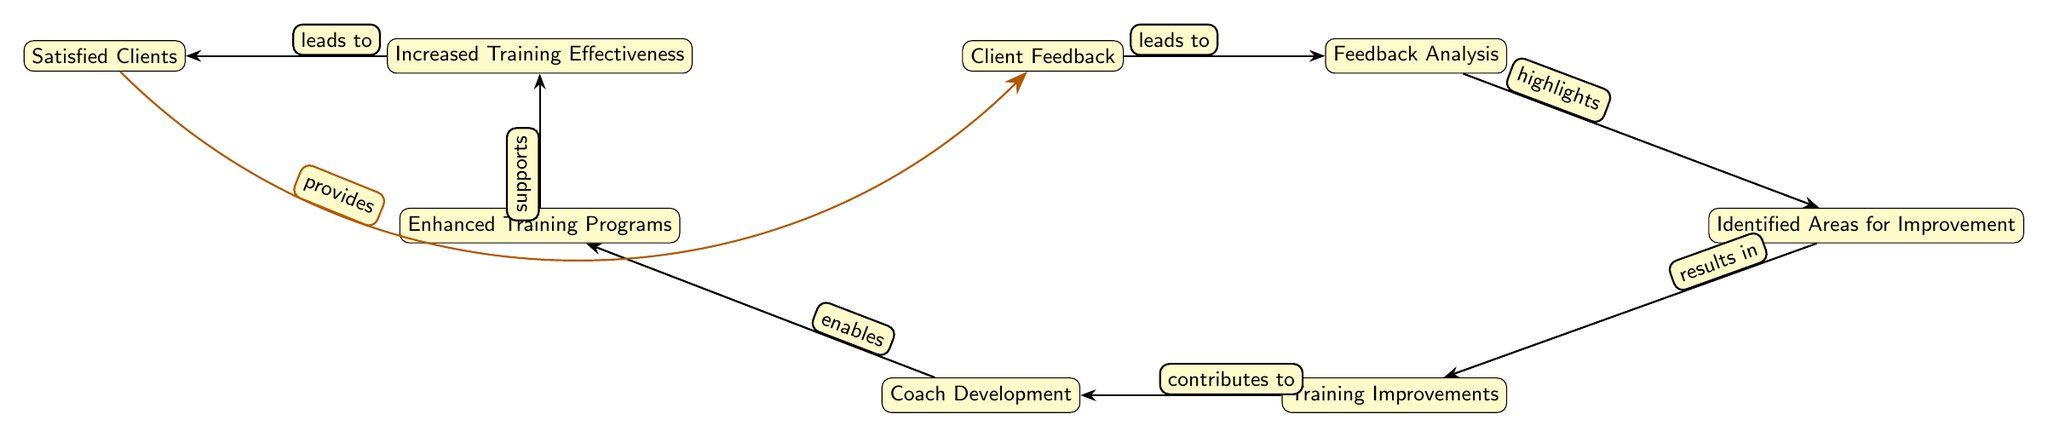What's the starting point of the feedback loop? The starting point of the feedback loop is indicated by the first node, which is "Client Feedback." This node initiates the process leading through various stages in the diagram.
Answer: Client Feedback How many nodes are in the diagram? The diagram contains a total of 8 nodes, each representing a key aspect of the feedback loop process.
Answer: 8 What does the "Feedback Analysis" node highlight? The "Feedback Analysis" node highlights "Identified Areas for Improvement," showing that the analysis focuses on recognizing specific areas where coaching can be strengthened.
Answer: Identified Areas for Improvement Which node follows "Training Improvements"? The node that follows "Training Improvements" in the flow of the diagram is "Coach Development." This indicates that improvements in training directly contribute to the development of coaches.
Answer: Coach Development What outcome does "Enhanced Training Programs" support? "Enhanced Training Programs" supports "Increased Training Effectiveness," indicating that improved training programs lead to better effectiveness in leadership coaching.
Answer: Increased Training Effectiveness What action results from "Identified Areas for Improvement"? The action that results from "Identified Areas for Improvement" is "Training Improvements," showing that identifying the areas prompts enhancements in training approaches.
Answer: Training Improvements What effect does "Satisfied Clients" have on the feedback loop? "Satisfied Clients" provides feedback back to "Client Feedback," indicating that positive client experiences contribute to the cycle of continuous improvement through their feedback.
Answer: Provides Which relationship connects "Enhanced Training Programs" to "Increased Training Effectiveness"? The relationship that connects "Enhanced Training Programs" to "Increased Training Effectiveness" is represented by "supports," indicating that one helps facilitate the other.
Answer: Supports How does "Feedback Analysis" relate to "Identified Areas for Improvement"? The relationship between these nodes is characterized by "highlights," illustrating that feedback analysis reveals key areas that need attention and improvement within the coaching programs.
Answer: Highlights 